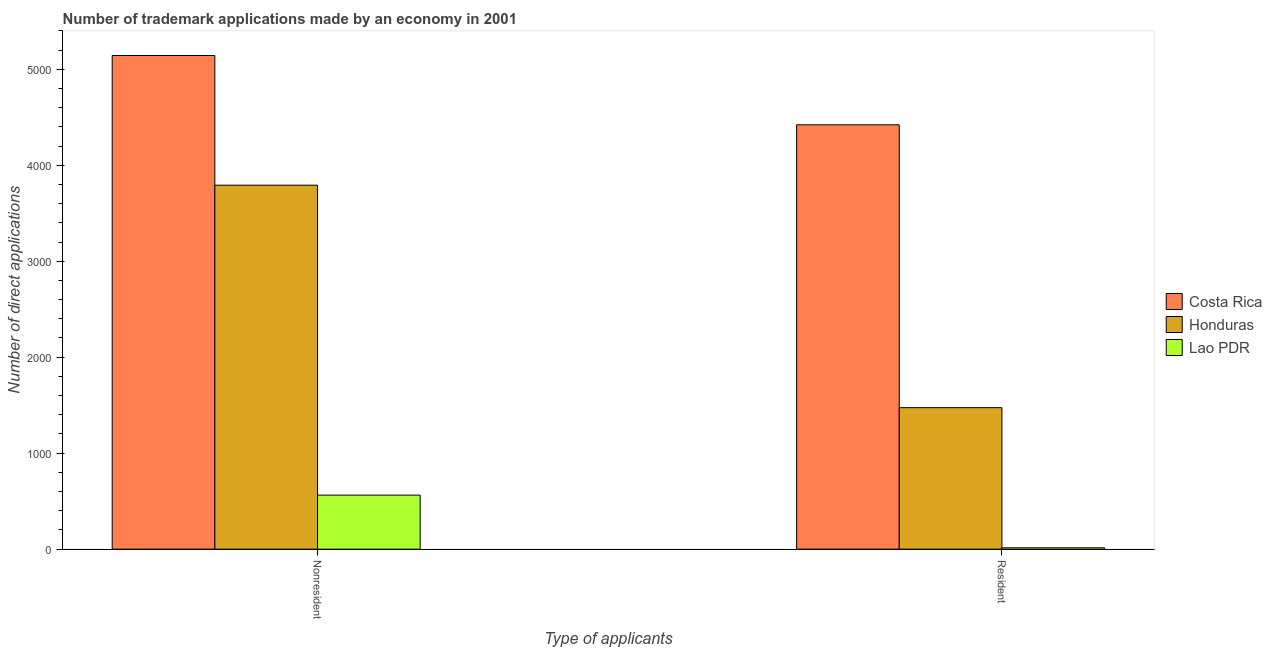How many different coloured bars are there?
Make the answer very short. 3. How many groups of bars are there?
Ensure brevity in your answer.  2. Are the number of bars per tick equal to the number of legend labels?
Your answer should be compact. Yes. Are the number of bars on each tick of the X-axis equal?
Give a very brief answer. Yes. How many bars are there on the 2nd tick from the left?
Offer a very short reply. 3. How many bars are there on the 2nd tick from the right?
Give a very brief answer. 3. What is the label of the 2nd group of bars from the left?
Your answer should be very brief. Resident. What is the number of trademark applications made by non residents in Costa Rica?
Offer a very short reply. 5143. Across all countries, what is the maximum number of trademark applications made by non residents?
Your response must be concise. 5143. Across all countries, what is the minimum number of trademark applications made by residents?
Ensure brevity in your answer.  14. In which country was the number of trademark applications made by non residents minimum?
Your response must be concise. Lao PDR. What is the total number of trademark applications made by residents in the graph?
Your response must be concise. 5909. What is the difference between the number of trademark applications made by residents in Lao PDR and that in Honduras?
Your answer should be compact. -1460. What is the difference between the number of trademark applications made by non residents in Lao PDR and the number of trademark applications made by residents in Honduras?
Your answer should be very brief. -911. What is the average number of trademark applications made by non residents per country?
Offer a terse response. 3166. What is the difference between the number of trademark applications made by non residents and number of trademark applications made by residents in Lao PDR?
Your answer should be very brief. 549. What is the ratio of the number of trademark applications made by non residents in Costa Rica to that in Lao PDR?
Ensure brevity in your answer.  9.13. Is the number of trademark applications made by non residents in Costa Rica less than that in Honduras?
Keep it short and to the point. No. What does the 2nd bar from the left in Resident represents?
Provide a succinct answer. Honduras. What does the 1st bar from the right in Nonresident represents?
Give a very brief answer. Lao PDR. Are all the bars in the graph horizontal?
Make the answer very short. No. How many countries are there in the graph?
Ensure brevity in your answer.  3. What is the difference between two consecutive major ticks on the Y-axis?
Ensure brevity in your answer.  1000. Are the values on the major ticks of Y-axis written in scientific E-notation?
Give a very brief answer. No. Does the graph contain any zero values?
Ensure brevity in your answer.  No. Does the graph contain grids?
Ensure brevity in your answer.  No. Where does the legend appear in the graph?
Provide a succinct answer. Center right. How many legend labels are there?
Offer a terse response. 3. How are the legend labels stacked?
Provide a short and direct response. Vertical. What is the title of the graph?
Your answer should be very brief. Number of trademark applications made by an economy in 2001. What is the label or title of the X-axis?
Make the answer very short. Type of applicants. What is the label or title of the Y-axis?
Your answer should be compact. Number of direct applications. What is the Number of direct applications of Costa Rica in Nonresident?
Give a very brief answer. 5143. What is the Number of direct applications in Honduras in Nonresident?
Make the answer very short. 3792. What is the Number of direct applications of Lao PDR in Nonresident?
Make the answer very short. 563. What is the Number of direct applications of Costa Rica in Resident?
Make the answer very short. 4421. What is the Number of direct applications in Honduras in Resident?
Ensure brevity in your answer.  1474. What is the Number of direct applications in Lao PDR in Resident?
Offer a terse response. 14. Across all Type of applicants, what is the maximum Number of direct applications in Costa Rica?
Offer a very short reply. 5143. Across all Type of applicants, what is the maximum Number of direct applications in Honduras?
Provide a succinct answer. 3792. Across all Type of applicants, what is the maximum Number of direct applications in Lao PDR?
Your response must be concise. 563. Across all Type of applicants, what is the minimum Number of direct applications of Costa Rica?
Make the answer very short. 4421. Across all Type of applicants, what is the minimum Number of direct applications of Honduras?
Keep it short and to the point. 1474. Across all Type of applicants, what is the minimum Number of direct applications of Lao PDR?
Give a very brief answer. 14. What is the total Number of direct applications of Costa Rica in the graph?
Give a very brief answer. 9564. What is the total Number of direct applications in Honduras in the graph?
Your answer should be compact. 5266. What is the total Number of direct applications in Lao PDR in the graph?
Ensure brevity in your answer.  577. What is the difference between the Number of direct applications in Costa Rica in Nonresident and that in Resident?
Provide a succinct answer. 722. What is the difference between the Number of direct applications in Honduras in Nonresident and that in Resident?
Give a very brief answer. 2318. What is the difference between the Number of direct applications in Lao PDR in Nonresident and that in Resident?
Your response must be concise. 549. What is the difference between the Number of direct applications of Costa Rica in Nonresident and the Number of direct applications of Honduras in Resident?
Your answer should be very brief. 3669. What is the difference between the Number of direct applications of Costa Rica in Nonresident and the Number of direct applications of Lao PDR in Resident?
Ensure brevity in your answer.  5129. What is the difference between the Number of direct applications in Honduras in Nonresident and the Number of direct applications in Lao PDR in Resident?
Offer a terse response. 3778. What is the average Number of direct applications in Costa Rica per Type of applicants?
Ensure brevity in your answer.  4782. What is the average Number of direct applications in Honduras per Type of applicants?
Offer a very short reply. 2633. What is the average Number of direct applications of Lao PDR per Type of applicants?
Your response must be concise. 288.5. What is the difference between the Number of direct applications of Costa Rica and Number of direct applications of Honduras in Nonresident?
Give a very brief answer. 1351. What is the difference between the Number of direct applications in Costa Rica and Number of direct applications in Lao PDR in Nonresident?
Your answer should be very brief. 4580. What is the difference between the Number of direct applications in Honduras and Number of direct applications in Lao PDR in Nonresident?
Your response must be concise. 3229. What is the difference between the Number of direct applications of Costa Rica and Number of direct applications of Honduras in Resident?
Ensure brevity in your answer.  2947. What is the difference between the Number of direct applications in Costa Rica and Number of direct applications in Lao PDR in Resident?
Offer a terse response. 4407. What is the difference between the Number of direct applications in Honduras and Number of direct applications in Lao PDR in Resident?
Ensure brevity in your answer.  1460. What is the ratio of the Number of direct applications in Costa Rica in Nonresident to that in Resident?
Provide a short and direct response. 1.16. What is the ratio of the Number of direct applications in Honduras in Nonresident to that in Resident?
Your answer should be very brief. 2.57. What is the ratio of the Number of direct applications of Lao PDR in Nonresident to that in Resident?
Your response must be concise. 40.21. What is the difference between the highest and the second highest Number of direct applications of Costa Rica?
Keep it short and to the point. 722. What is the difference between the highest and the second highest Number of direct applications in Honduras?
Your response must be concise. 2318. What is the difference between the highest and the second highest Number of direct applications of Lao PDR?
Offer a terse response. 549. What is the difference between the highest and the lowest Number of direct applications of Costa Rica?
Provide a succinct answer. 722. What is the difference between the highest and the lowest Number of direct applications in Honduras?
Your answer should be very brief. 2318. What is the difference between the highest and the lowest Number of direct applications of Lao PDR?
Ensure brevity in your answer.  549. 